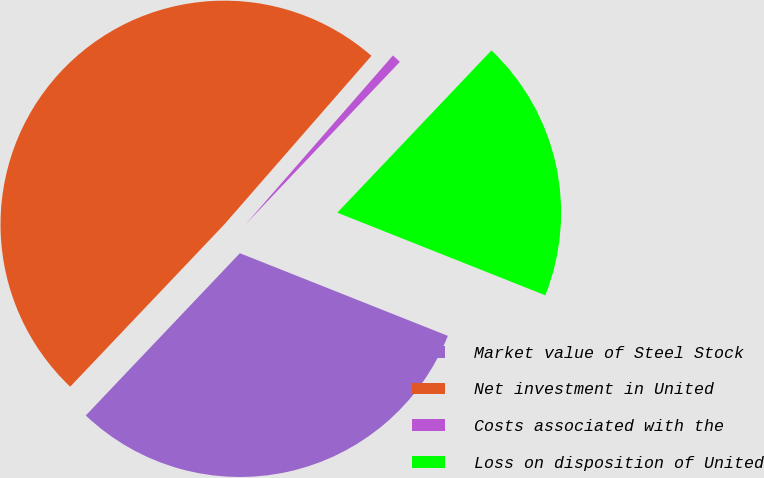Convert chart. <chart><loc_0><loc_0><loc_500><loc_500><pie_chart><fcel>Market value of Steel Stock<fcel>Net investment in United<fcel>Costs associated with the<fcel>Loss on disposition of United<nl><fcel>31.07%<fcel>49.33%<fcel>0.67%<fcel>18.93%<nl></chart> 